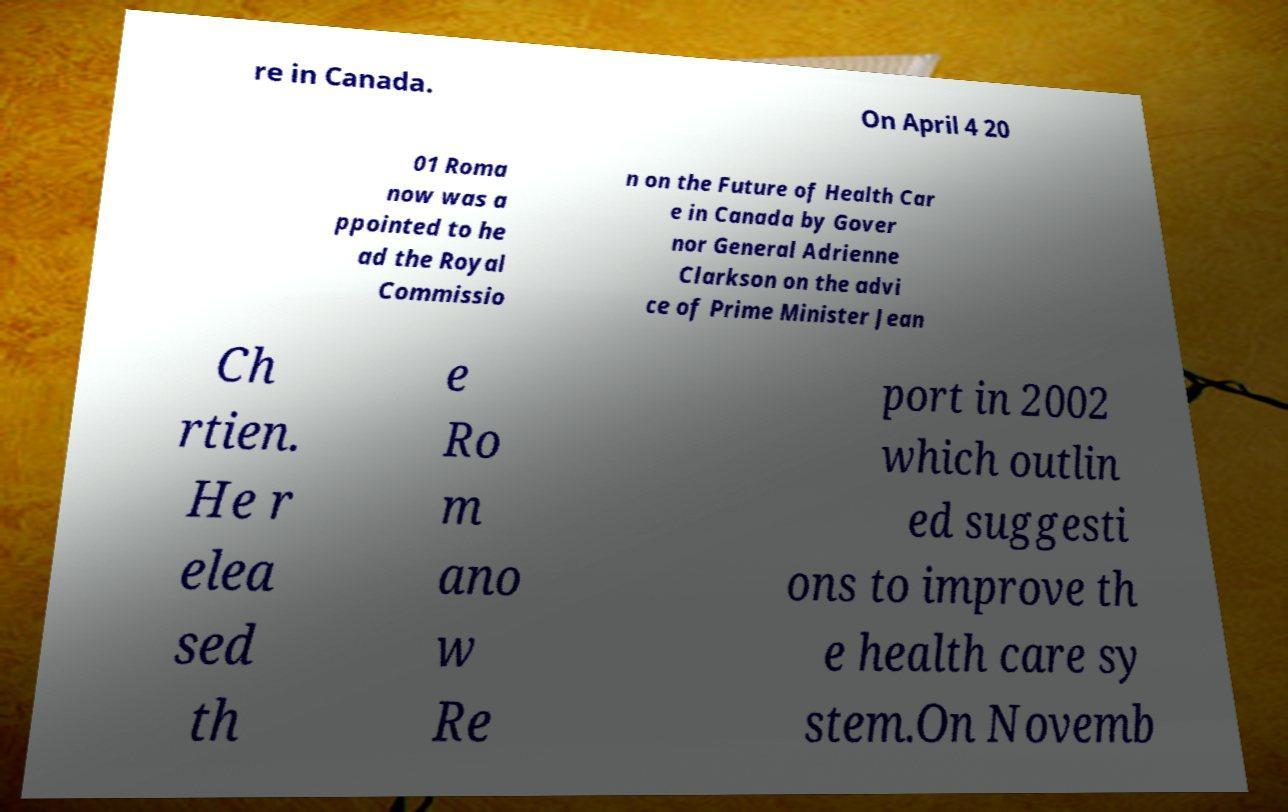Could you assist in decoding the text presented in this image and type it out clearly? re in Canada. On April 4 20 01 Roma now was a ppointed to he ad the Royal Commissio n on the Future of Health Car e in Canada by Gover nor General Adrienne Clarkson on the advi ce of Prime Minister Jean Ch rtien. He r elea sed th e Ro m ano w Re port in 2002 which outlin ed suggesti ons to improve th e health care sy stem.On Novemb 